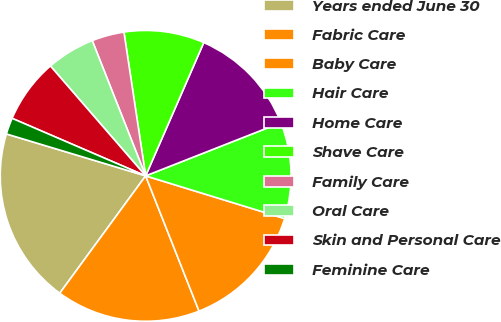<chart> <loc_0><loc_0><loc_500><loc_500><pie_chart><fcel>Years ended June 30<fcel>Fabric Care<fcel>Baby Care<fcel>Hair Care<fcel>Home Care<fcel>Shave Care<fcel>Family Care<fcel>Oral Care<fcel>Skin and Personal Care<fcel>Feminine Care<nl><fcel>19.6%<fcel>16.04%<fcel>14.27%<fcel>10.71%<fcel>12.49%<fcel>8.93%<fcel>3.6%<fcel>5.38%<fcel>7.16%<fcel>1.82%<nl></chart> 